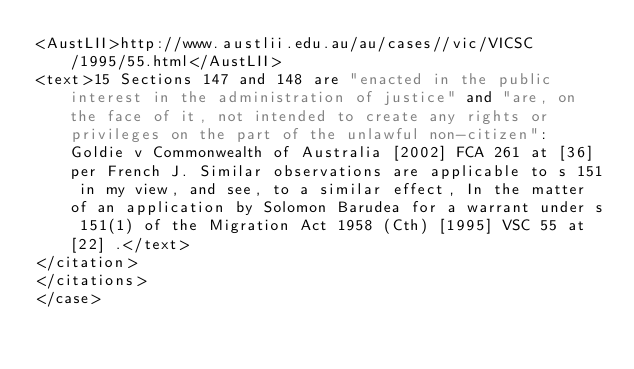Convert code to text. <code><loc_0><loc_0><loc_500><loc_500><_XML_><AustLII>http://www.austlii.edu.au/au/cases//vic/VICSC/1995/55.html</AustLII>
<text>15 Sections 147 and 148 are "enacted in the public interest in the administration of justice" and "are, on the face of it, not intended to create any rights or privileges on the part of the unlawful non-citizen": Goldie v Commonwealth of Australia [2002] FCA 261 at [36] per French J. Similar observations are applicable to s 151 in my view, and see, to a similar effect, In the matter of an application by Solomon Barudea for a warrant under s 151(1) of the Migration Act 1958 (Cth) [1995] VSC 55 at [22] .</text>
</citation>
</citations>
</case></code> 